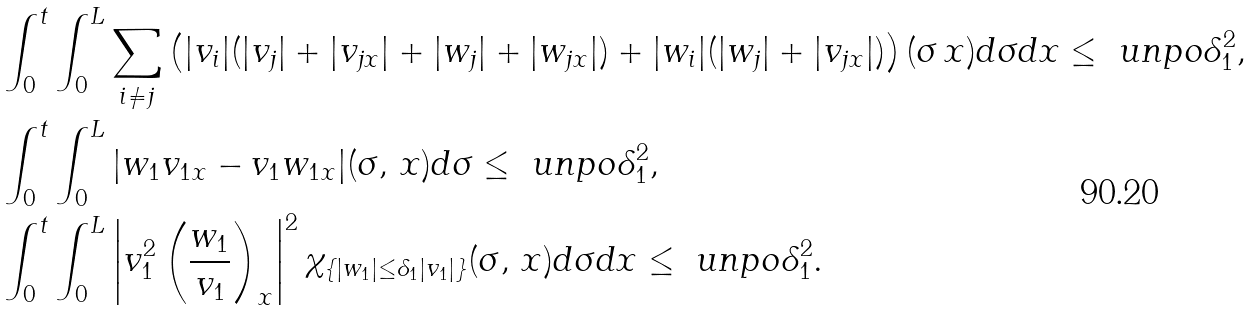<formula> <loc_0><loc_0><loc_500><loc_500>& \int _ { 0 } ^ { t } \int _ { 0 } ^ { L } \sum _ { i \neq j } \left ( | v _ { i } | ( | v _ { j } | + | v _ { j x } | + | w _ { j } | + | w _ { j x } | ) + | w _ { i } | ( | w _ { j } | + | v _ { j x } | ) \right ) ( \sigma \, x ) d \sigma d x \leq \ u n p o \delta _ { 1 } ^ { 2 } , \\ & \int _ { 0 } ^ { t } \int _ { 0 } ^ { L } | w _ { 1 } v _ { 1 x } - v _ { 1 } w _ { 1 x } | ( \sigma , \, x ) d \sigma \leq \ u n p o \delta _ { 1 } ^ { 2 } , \\ & \int _ { 0 } ^ { t } \int _ { 0 } ^ { L } \left | v _ { 1 } ^ { 2 } \left ( \frac { w _ { 1 } } { v _ { 1 } } \right ) _ { x } \right | ^ { 2 } \chi _ { \{ | w _ { 1 } | \leq \delta _ { 1 } | v _ { 1 } | \} } ( \sigma , \, x ) d \sigma d x \leq \ u n p o \delta _ { 1 } ^ { 2 } . \\</formula> 